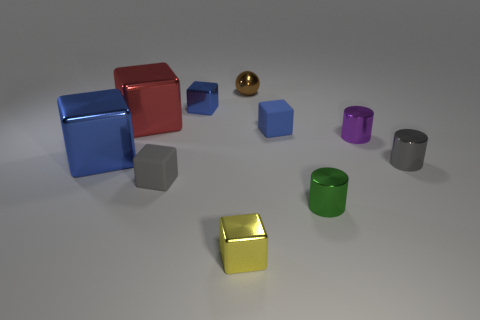Subtract all tiny blue cubes. How many cubes are left? 4 Subtract all red blocks. How many blocks are left? 5 Subtract all red cylinders. How many blue cubes are left? 3 Subtract 1 cylinders. How many cylinders are left? 2 Subtract all gray cylinders. Subtract all purple cubes. How many cylinders are left? 2 Add 9 big purple metal blocks. How many big purple metal blocks exist? 9 Subtract 0 red spheres. How many objects are left? 10 Subtract all cubes. How many objects are left? 4 Subtract all red matte cylinders. Subtract all brown metallic balls. How many objects are left? 9 Add 7 tiny brown metal objects. How many tiny brown metal objects are left? 8 